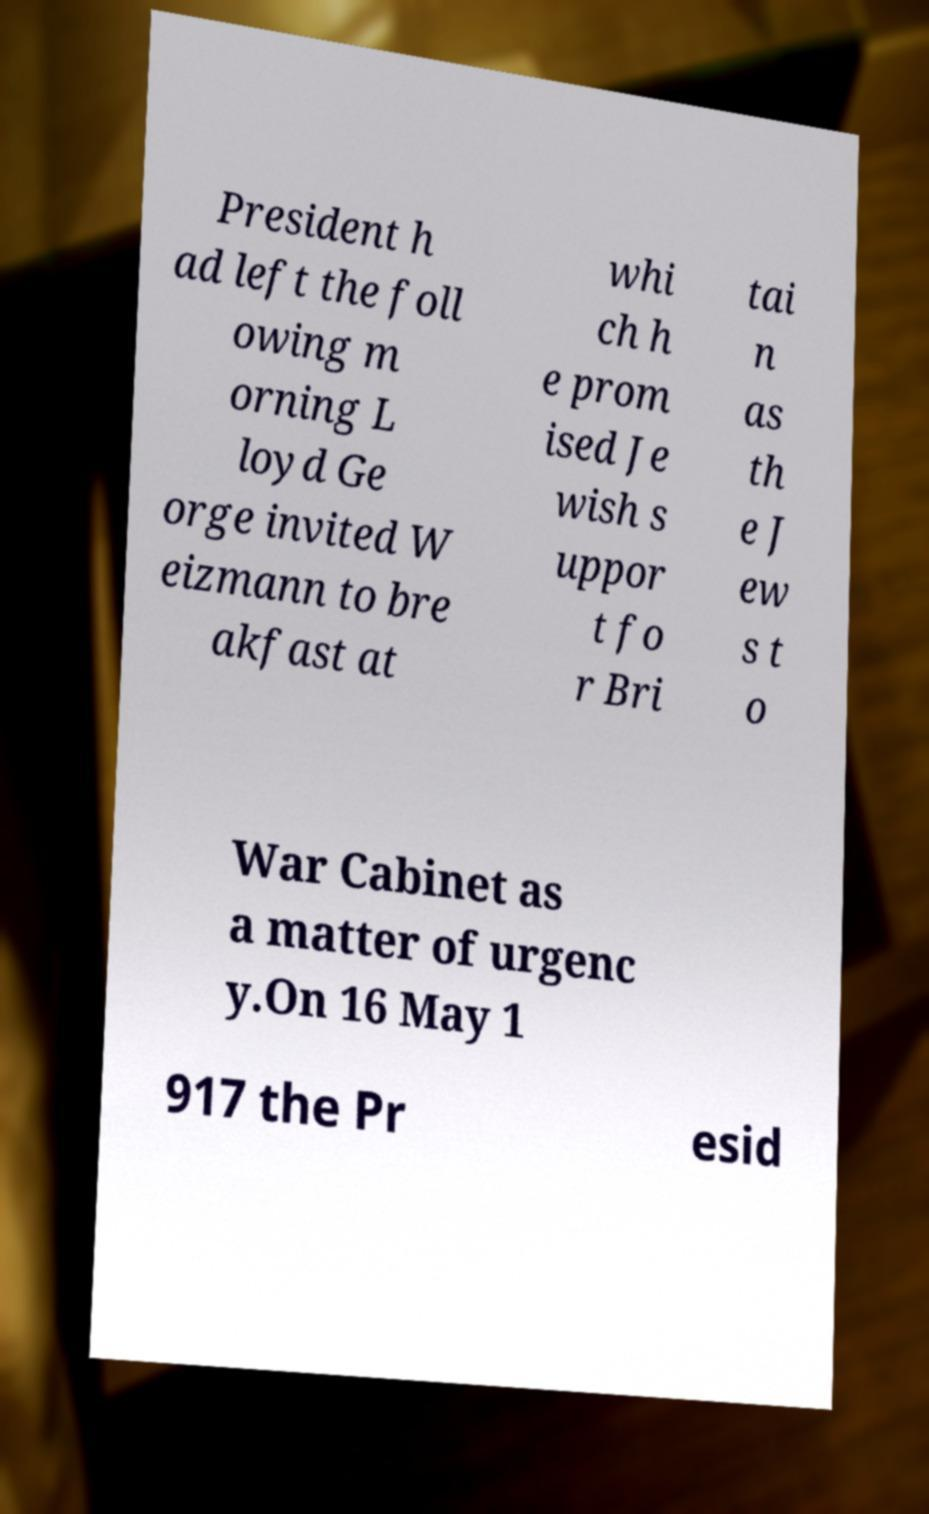For documentation purposes, I need the text within this image transcribed. Could you provide that? President h ad left the foll owing m orning L loyd Ge orge invited W eizmann to bre akfast at whi ch h e prom ised Je wish s uppor t fo r Bri tai n as th e J ew s t o War Cabinet as a matter of urgenc y.On 16 May 1 917 the Pr esid 